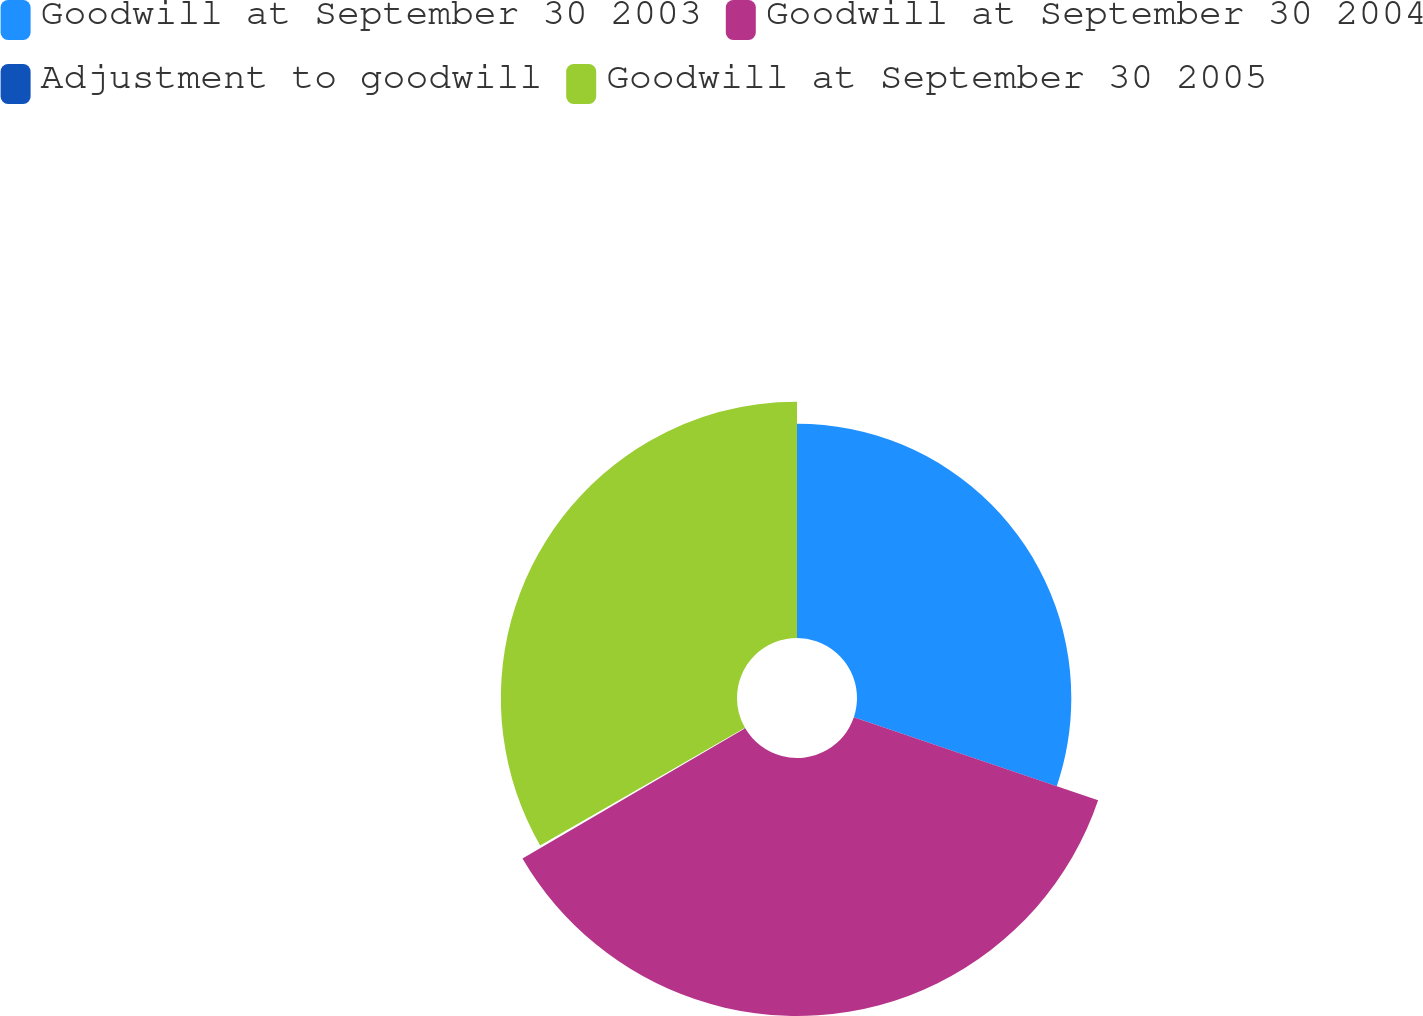Convert chart to OTSL. <chart><loc_0><loc_0><loc_500><loc_500><pie_chart><fcel>Goodwill at September 30 2003<fcel>Goodwill at September 30 2004<fcel>Adjustment to goodwill<fcel>Goodwill at September 30 2005<nl><fcel>30.21%<fcel>36.37%<fcel>0.13%<fcel>33.29%<nl></chart> 